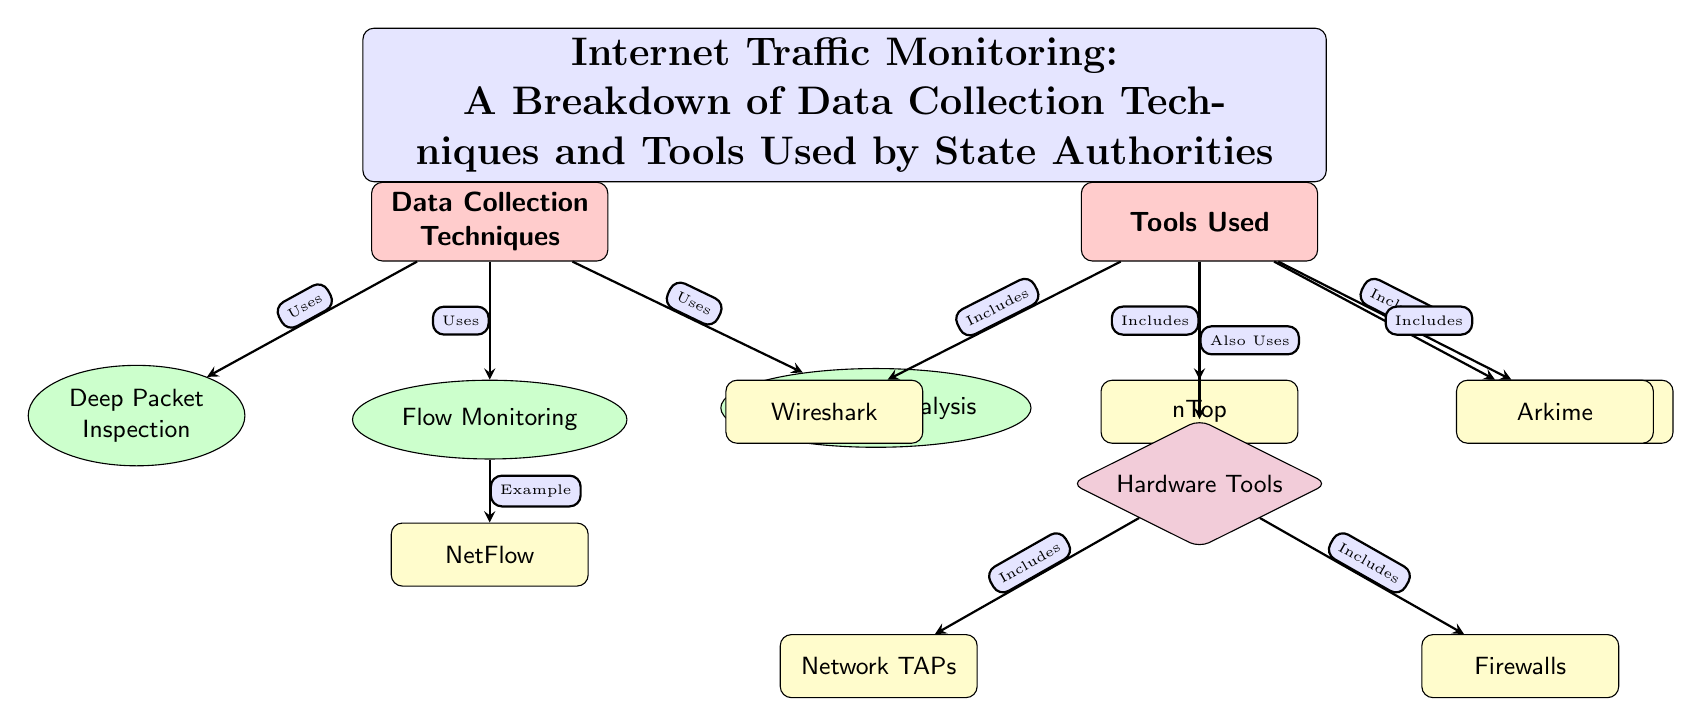What is the title of the diagram? The title is located at the top of the diagram, summarizing its main focus on internet traffic monitoring and data collection techniques used by state authorities.
Answer: Internet Traffic Monitoring: A Breakdown of Data Collection Techniques and Tools Used by State Authorities How many main nodes are there in the diagram? The diagram contains two main nodes located horizontally across the top, labeled "Data Collection Techniques" and "Tools Used".
Answer: 2 Which data collection technique is linked to an example tool? The flow monitoring technique is directly connected to the tool example "NetFlow" located below it in the diagram.
Answer: NetFlow Name one tool included in the "Tools Used" section. In the "Tools Used" section, there are several tools listed, including "Wireshark", "nTop", "Cisco NetFlow", and "Arkime". The question can be answered with any one of these.
Answer: Wireshark How many tools are listed under the "Tools Used" section? There are four tools listed under the "Tools Used" section: "Wireshark", "nTop", "Cisco NetFlow", and "Arkime". Counting them gives a total of four.
Answer: 4 What is the relationship between "Data Collection Techniques" and "Tools Used"? The diagram indicates a requirement relationship, as denoted by the directional arrow that says "Requires", indicating that the techniques need the tools to be effective.
Answer: Requires Which technique requires the use of hardware tools? The diagram clearly shows that "Data Collection Techniques" includes a connection stating that it "Also Uses" hardware tools, indicating a relationship that implies dependency on hardware for certain techniques.
Answer: Hardware Tools What are the two types of hardware tools mentioned? The diagram lists "Network TAPs" and "Firewalls" as the two types of hardware tools found in the "Hardware Tools" section, highlighting essentials used in traffic monitoring.
Answer: Network TAPs and Firewalls Which technique is placed directly below "Data Collection Techniques"? The "Flow Monitoring" technique is positioned directly below "Data Collection Techniques," indicating its connection as one of the methods used.
Answer: Flow Monitoring 